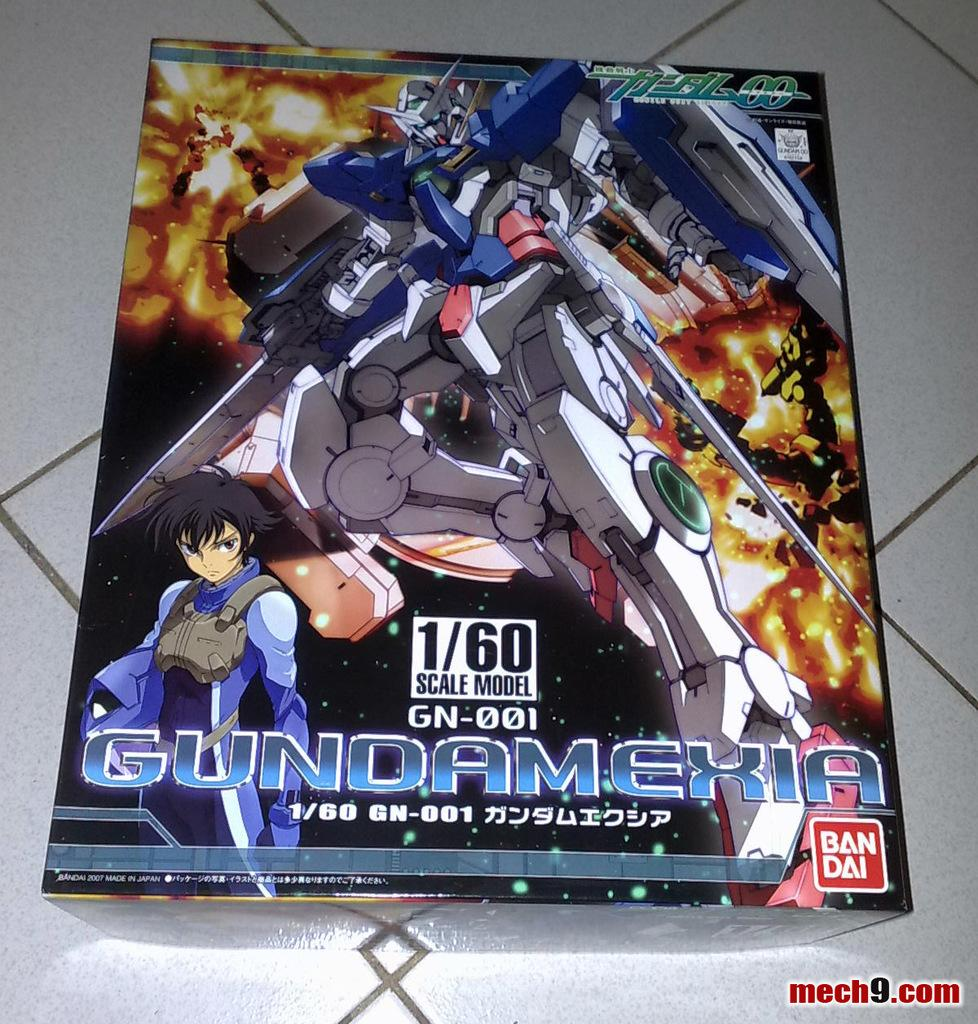<image>
Summarize the visual content of the image. A Ban Dai product, Gundamexia is item number GN-001 